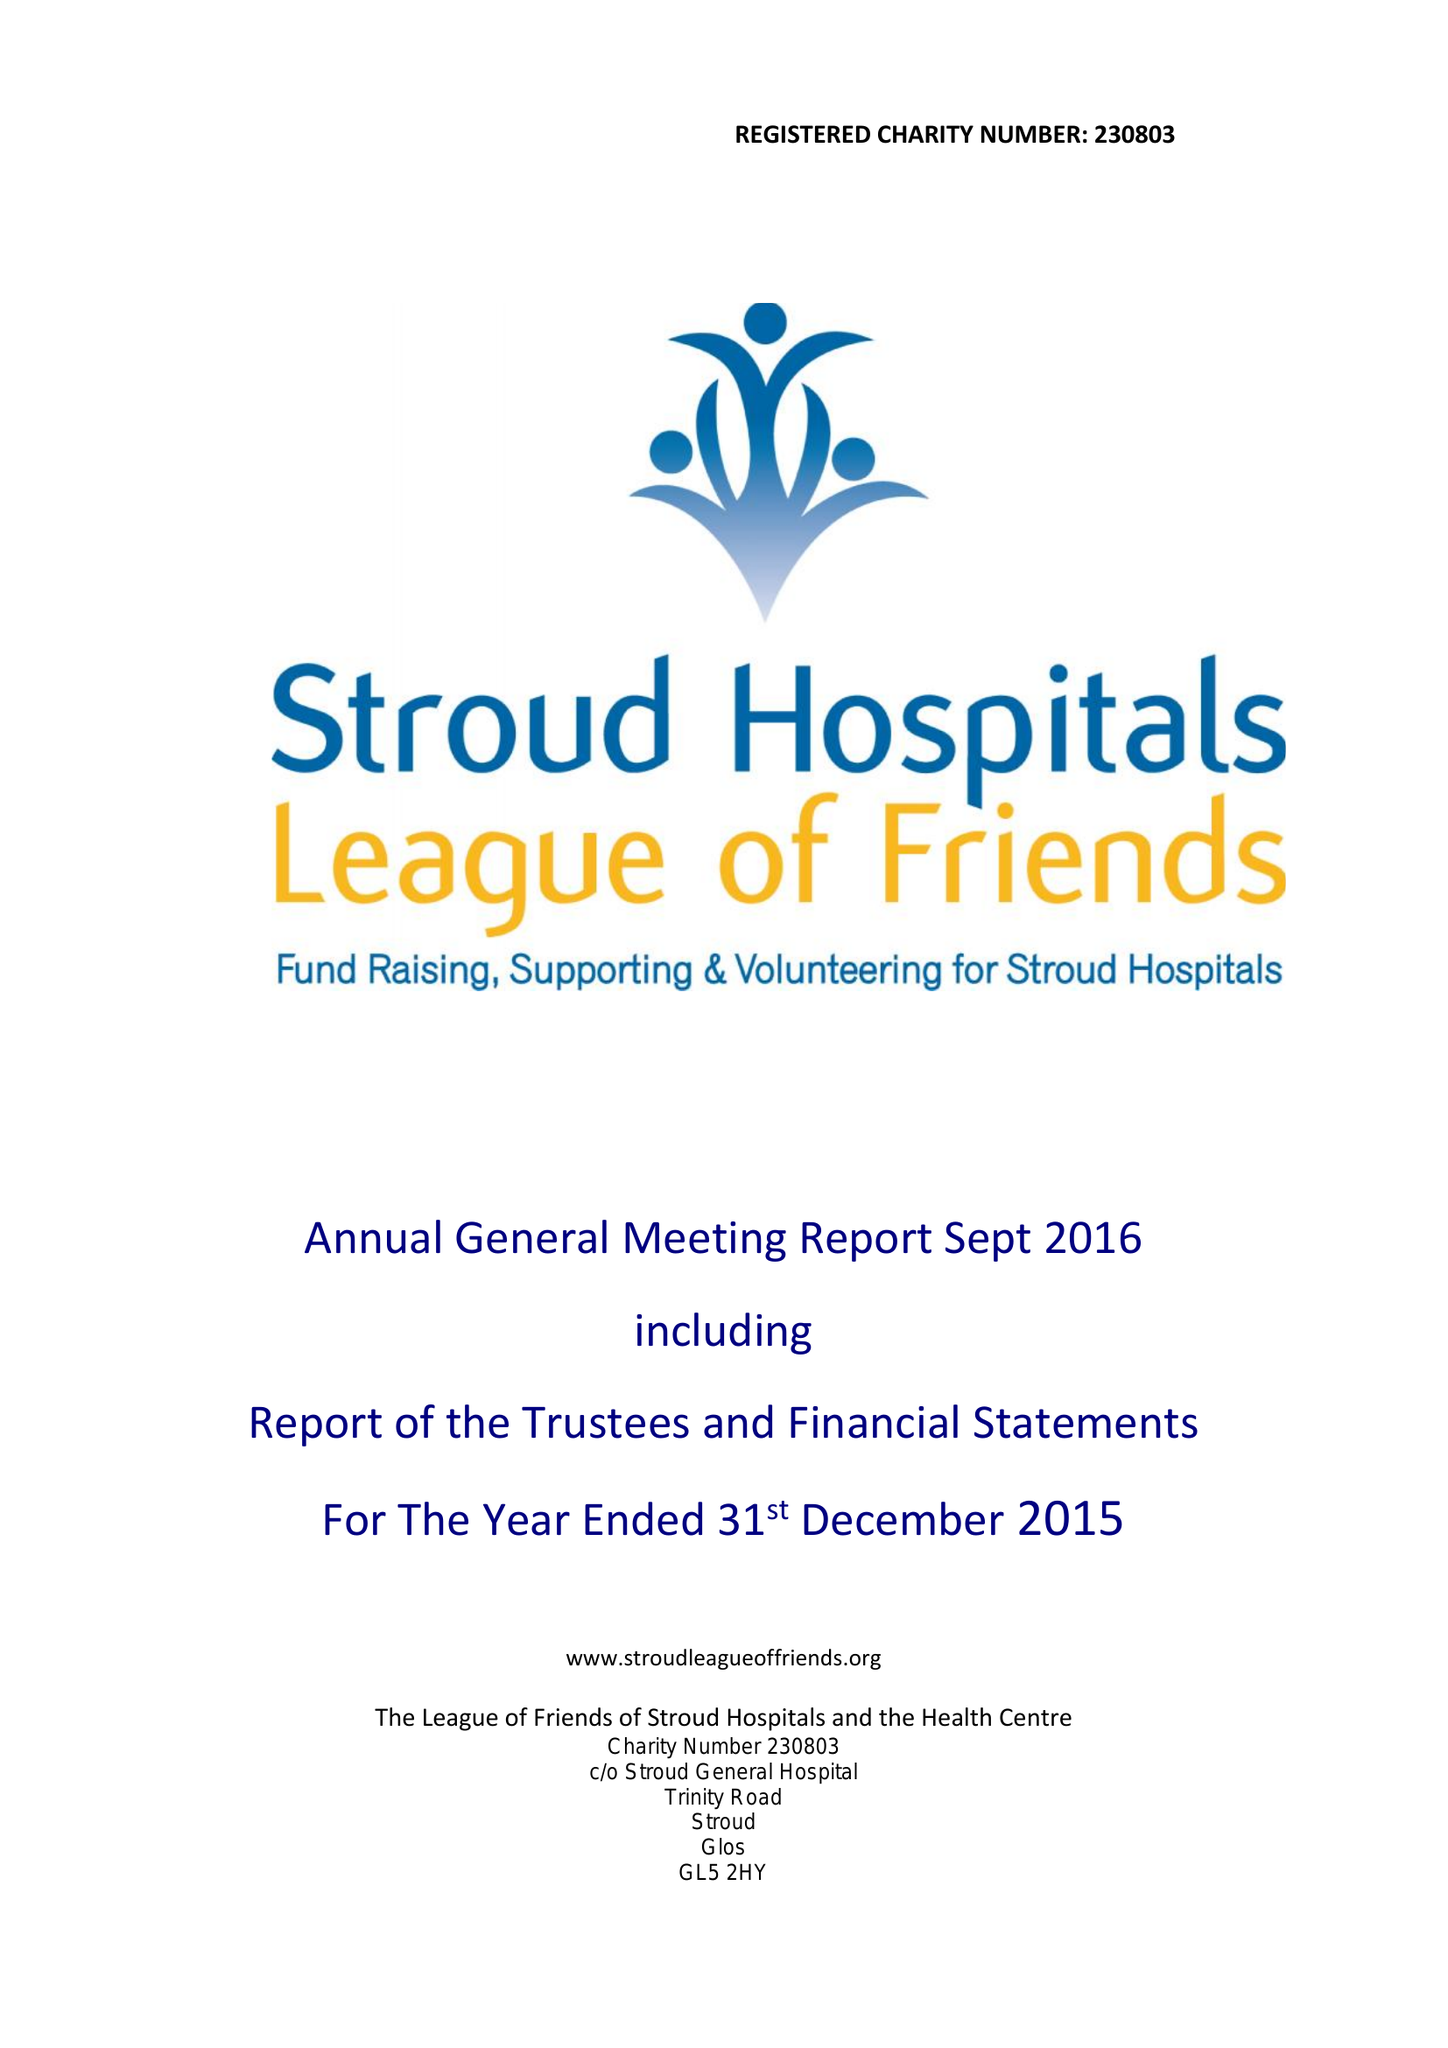What is the value for the address__post_town?
Answer the question using a single word or phrase. STROUD 